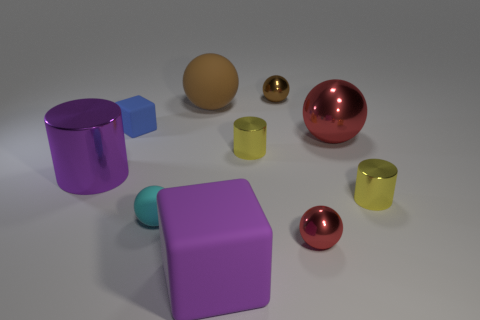What is the size of the other metal sphere that is the same color as the large metallic ball?
Your answer should be compact. Small. What shape is the big object that is the same color as the big metal cylinder?
Make the answer very short. Cube. The purple metal cylinder has what size?
Your response must be concise. Large. What number of brown balls have the same size as the cyan rubber sphere?
Ensure brevity in your answer.  1. Does the big cylinder have the same color as the small matte ball?
Your answer should be very brief. No. Is the tiny brown ball to the right of the small rubber sphere made of the same material as the red thing behind the cyan thing?
Your response must be concise. Yes. Are there more green things than small brown balls?
Provide a short and direct response. No. Is there anything else that is the same color as the tiny matte ball?
Ensure brevity in your answer.  No. Is the small red object made of the same material as the tiny cube?
Give a very brief answer. No. Is the number of tiny blue metal cylinders less than the number of small yellow things?
Provide a short and direct response. Yes. 